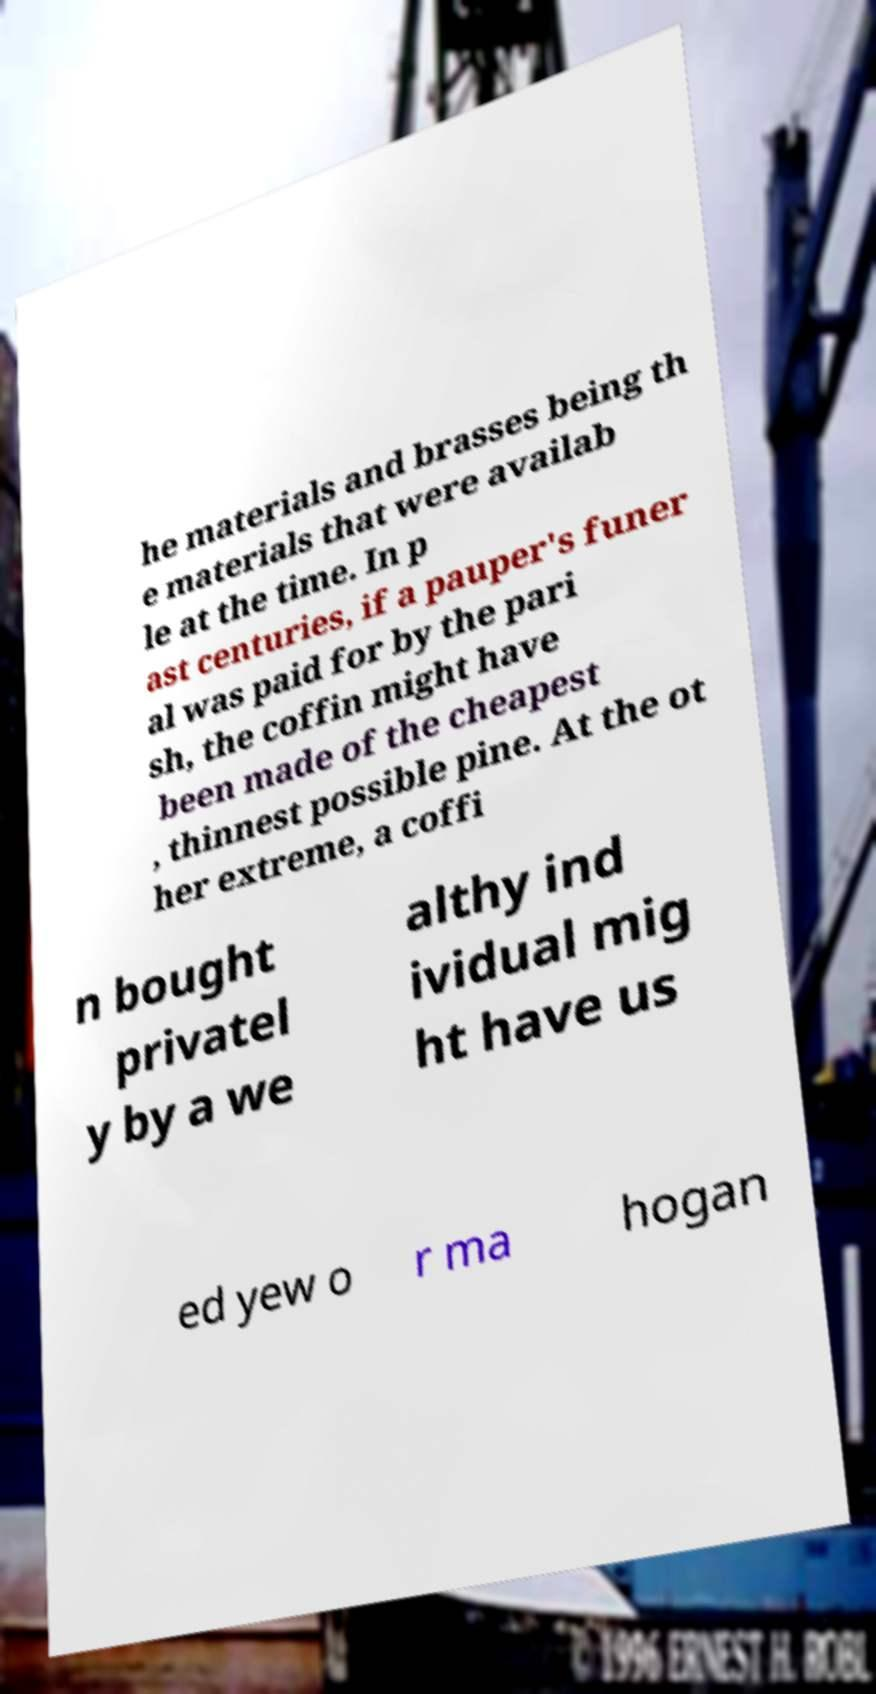Can you read and provide the text displayed in the image?This photo seems to have some interesting text. Can you extract and type it out for me? he materials and brasses being th e materials that were availab le at the time. In p ast centuries, if a pauper's funer al was paid for by the pari sh, the coffin might have been made of the cheapest , thinnest possible pine. At the ot her extreme, a coffi n bought privatel y by a we althy ind ividual mig ht have us ed yew o r ma hogan 